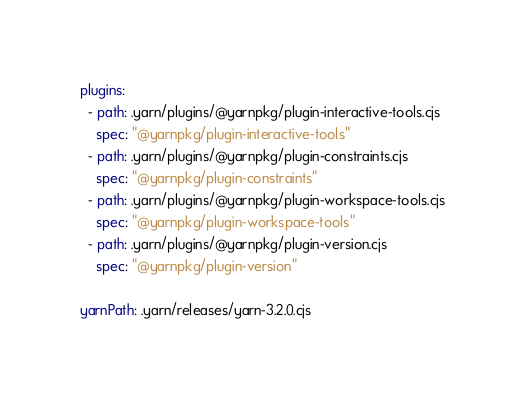Convert code to text. <code><loc_0><loc_0><loc_500><loc_500><_YAML_>plugins:
  - path: .yarn/plugins/@yarnpkg/plugin-interactive-tools.cjs
    spec: "@yarnpkg/plugin-interactive-tools"
  - path: .yarn/plugins/@yarnpkg/plugin-constraints.cjs
    spec: "@yarnpkg/plugin-constraints"
  - path: .yarn/plugins/@yarnpkg/plugin-workspace-tools.cjs
    spec: "@yarnpkg/plugin-workspace-tools"
  - path: .yarn/plugins/@yarnpkg/plugin-version.cjs
    spec: "@yarnpkg/plugin-version"

yarnPath: .yarn/releases/yarn-3.2.0.cjs
</code> 